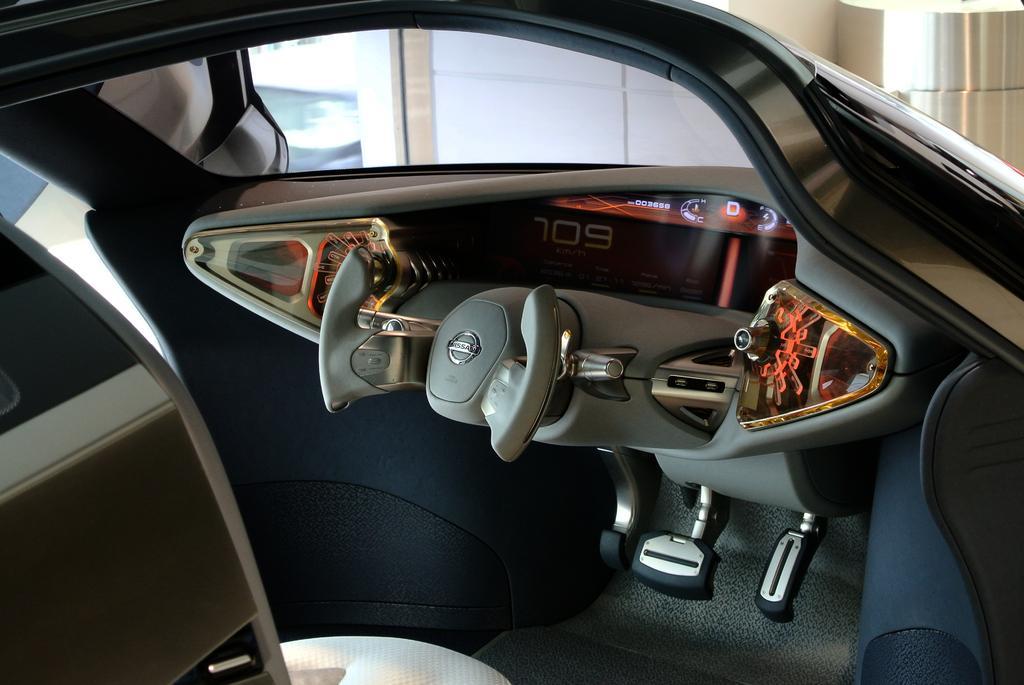Could you give a brief overview of what you see in this image? In this image we can see the inside view of the vehicle. In the background we can see the wall and also the pillar. 